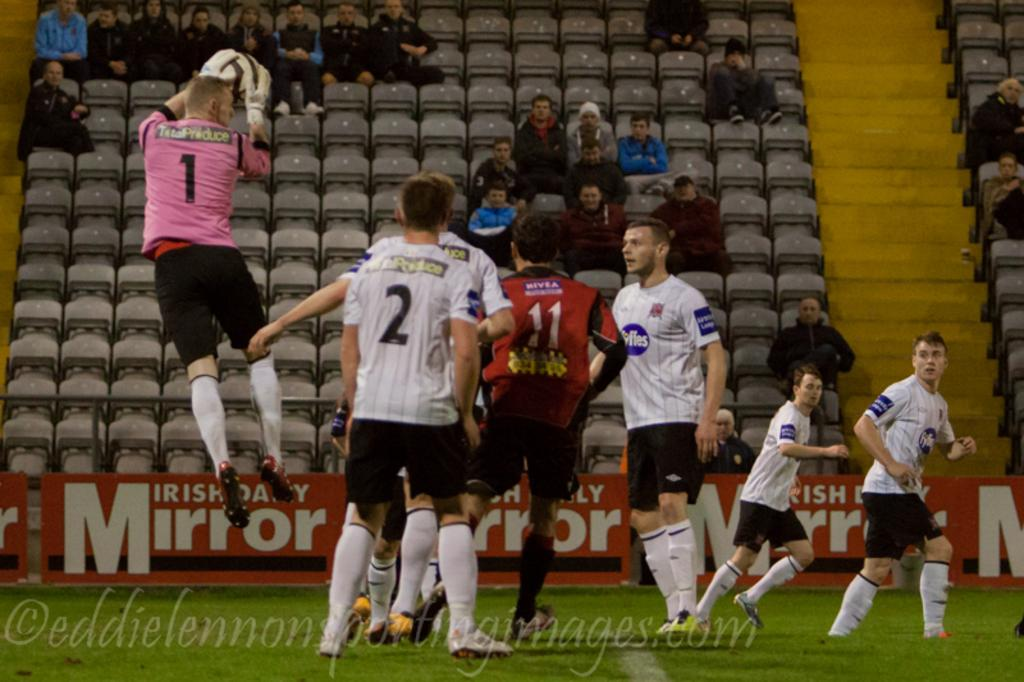<image>
Give a short and clear explanation of the subsequent image. A group of men are playing soccer with a sign about a mirror behind them. 